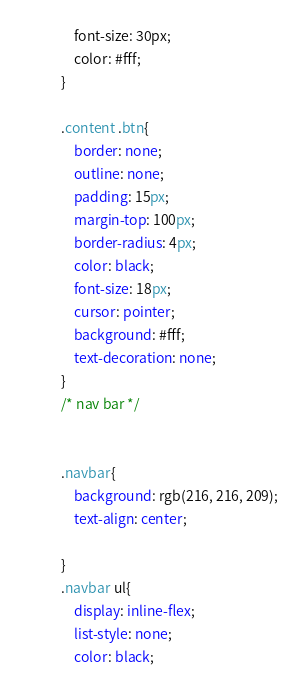<code> <loc_0><loc_0><loc_500><loc_500><_CSS_>    font-size: 30px;
    color: #fff;
}

.content .btn{
    border: none;
    outline: none;
    padding: 15px;
    margin-top: 100px;
    border-radius: 4px;
    color: black;
    font-size: 18px;
    cursor: pointer;
    background: #fff;
    text-decoration: none;
}
/* nav bar */
  

.navbar{
    background: rgb(216, 216, 209);
    text-align: center;    
    
}
.navbar ul{
    display: inline-flex;
    list-style: none;
    color: black;</code> 